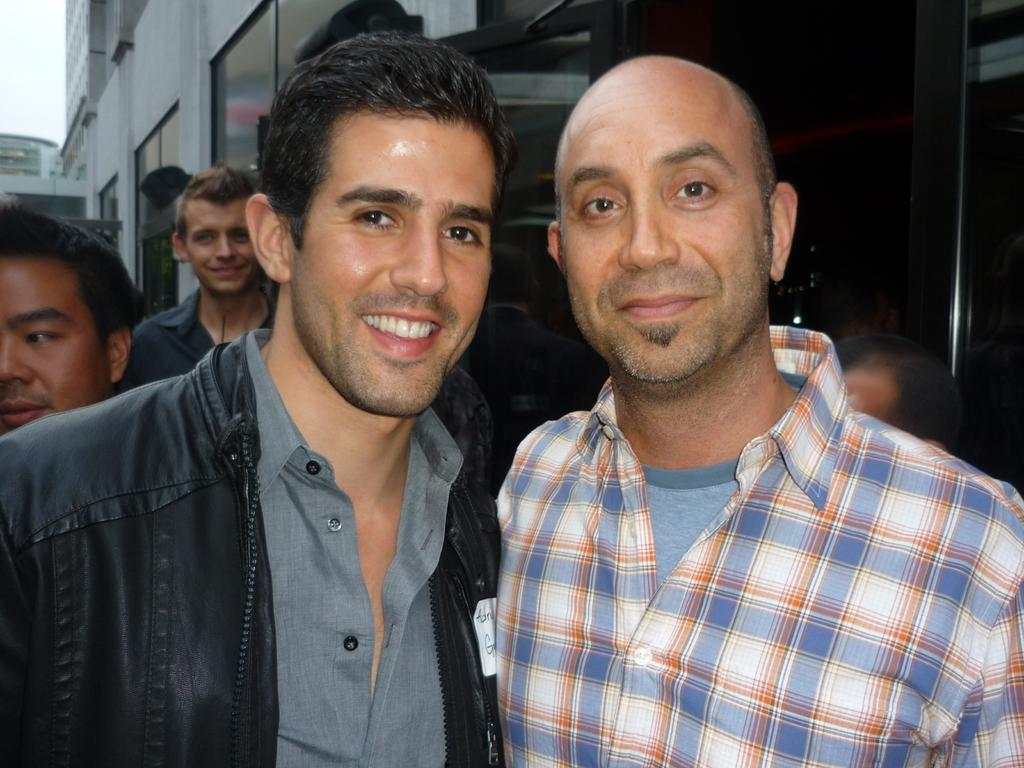What can be seen in the image? There are groups of people standing in the image. What can be seen in the distance behind the people? There are buildings visible in the background of the image. What else is visible in the background of the image? The sky is visible in the background of the image. How many minutes does it take for the horse to run across the image? There is no horse present in the image, so it is not possible to answer that question. 